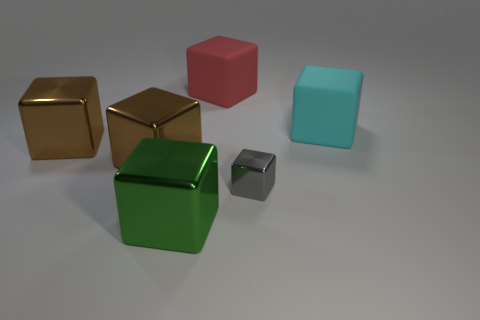What is the material of the other cyan object that is the same shape as the tiny object?
Your answer should be compact. Rubber. Is there any other thing that has the same material as the cyan cube?
Offer a very short reply. Yes. Is the large thing right of the tiny gray metallic cube made of the same material as the cube behind the cyan rubber block?
Make the answer very short. Yes. What is the color of the matte thing that is on the left side of the matte object that is in front of the rubber object left of the big cyan block?
Your response must be concise. Red. How many other objects are there of the same shape as the large cyan thing?
Ensure brevity in your answer.  5. What number of objects are large brown cubes or blocks that are on the left side of the cyan block?
Your response must be concise. 5. Is there a purple block that has the same size as the red block?
Offer a terse response. No. Does the big red cube have the same material as the small cube?
Give a very brief answer. No. What number of things are small metallic cubes or large red matte objects?
Make the answer very short. 2. What is the size of the cyan matte object?
Your answer should be very brief. Large. 